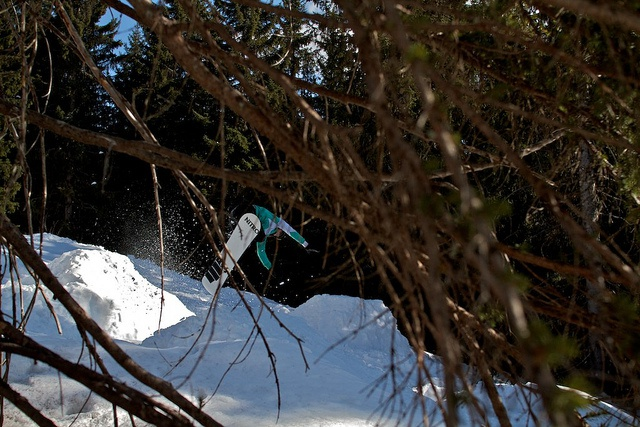Describe the objects in this image and their specific colors. I can see snowboard in black, darkgray, gray, and maroon tones and people in black, teal, and gray tones in this image. 